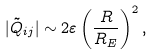<formula> <loc_0><loc_0><loc_500><loc_500>| \tilde { Q } _ { i j } | \sim 2 \varepsilon \left ( \frac { R } { R _ { E } } \right ) ^ { 2 } ,</formula> 